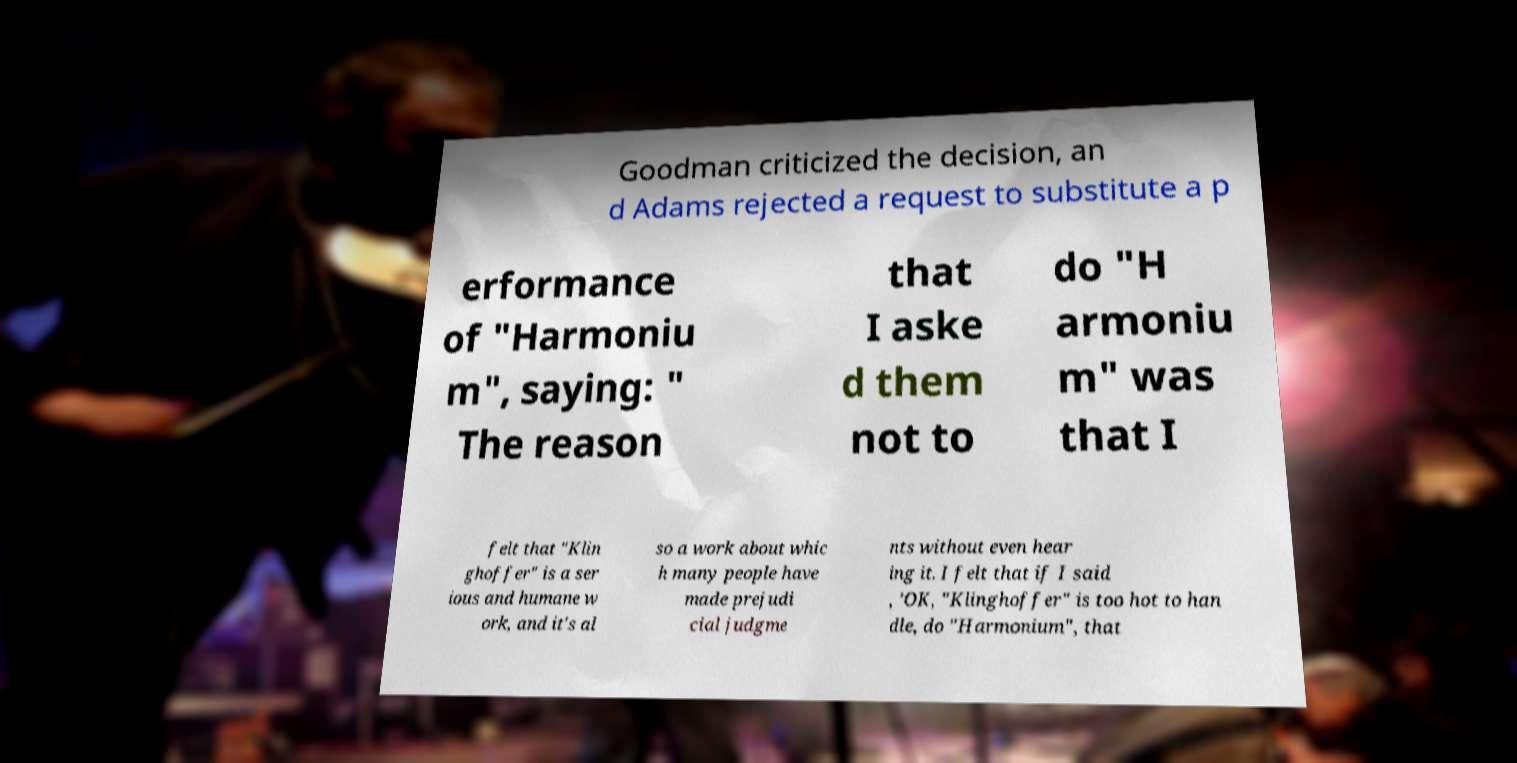There's text embedded in this image that I need extracted. Can you transcribe it verbatim? Goodman criticized the decision, an d Adams rejected a request to substitute a p erformance of "Harmoniu m", saying: " The reason that I aske d them not to do "H armoniu m" was that I felt that "Klin ghoffer" is a ser ious and humane w ork, and it's al so a work about whic h many people have made prejudi cial judgme nts without even hear ing it. I felt that if I said , 'OK, "Klinghoffer" is too hot to han dle, do "Harmonium", that 